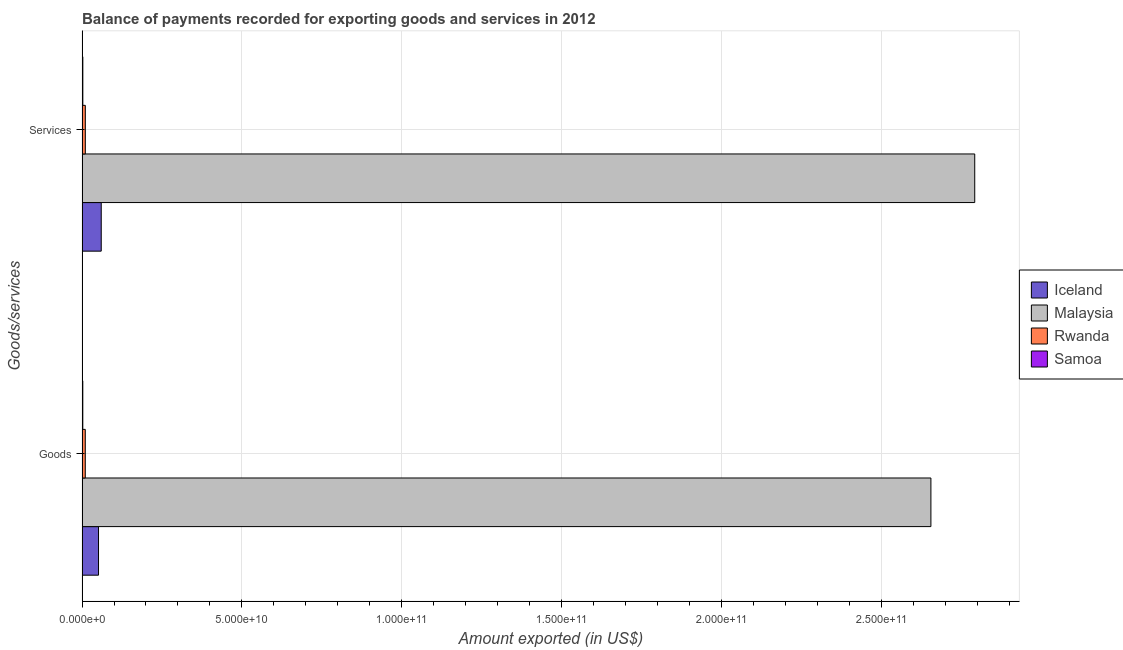How many different coloured bars are there?
Your response must be concise. 4. How many groups of bars are there?
Provide a succinct answer. 2. Are the number of bars per tick equal to the number of legend labels?
Your response must be concise. Yes. How many bars are there on the 1st tick from the top?
Your response must be concise. 4. What is the label of the 2nd group of bars from the top?
Keep it short and to the point. Goods. What is the amount of services exported in Malaysia?
Give a very brief answer. 2.79e+11. Across all countries, what is the maximum amount of services exported?
Your answer should be compact. 2.79e+11. Across all countries, what is the minimum amount of services exported?
Your answer should be compact. 2.51e+08. In which country was the amount of goods exported maximum?
Ensure brevity in your answer.  Malaysia. In which country was the amount of goods exported minimum?
Make the answer very short. Samoa. What is the total amount of goods exported in the graph?
Provide a succinct answer. 2.72e+11. What is the difference between the amount of services exported in Iceland and that in Samoa?
Your answer should be compact. 5.75e+09. What is the difference between the amount of goods exported in Samoa and the amount of services exported in Malaysia?
Offer a terse response. -2.79e+11. What is the average amount of services exported per country?
Keep it short and to the point. 7.16e+1. What is the difference between the amount of services exported and amount of goods exported in Malaysia?
Your answer should be compact. 1.37e+1. In how many countries, is the amount of services exported greater than 220000000000 US$?
Give a very brief answer. 1. What is the ratio of the amount of services exported in Rwanda to that in Samoa?
Give a very brief answer. 4.1. What does the 4th bar from the top in Services represents?
Your response must be concise. Iceland. What does the 3rd bar from the bottom in Services represents?
Provide a short and direct response. Rwanda. How many bars are there?
Keep it short and to the point. 8. How many countries are there in the graph?
Give a very brief answer. 4. What is the difference between two consecutive major ticks on the X-axis?
Give a very brief answer. 5.00e+1. Where does the legend appear in the graph?
Your answer should be compact. Center right. How are the legend labels stacked?
Give a very brief answer. Vertical. What is the title of the graph?
Provide a succinct answer. Balance of payments recorded for exporting goods and services in 2012. What is the label or title of the X-axis?
Offer a terse response. Amount exported (in US$). What is the label or title of the Y-axis?
Make the answer very short. Goods/services. What is the Amount exported (in US$) in Iceland in Goods?
Provide a short and direct response. 5.15e+09. What is the Amount exported (in US$) in Malaysia in Goods?
Ensure brevity in your answer.  2.66e+11. What is the Amount exported (in US$) of Rwanda in Goods?
Make the answer very short. 1.02e+09. What is the Amount exported (in US$) of Samoa in Goods?
Offer a very short reply. 2.42e+08. What is the Amount exported (in US$) in Iceland in Services?
Provide a succinct answer. 6.00e+09. What is the Amount exported (in US$) of Malaysia in Services?
Provide a short and direct response. 2.79e+11. What is the Amount exported (in US$) of Rwanda in Services?
Give a very brief answer. 1.03e+09. What is the Amount exported (in US$) of Samoa in Services?
Provide a short and direct response. 2.51e+08. Across all Goods/services, what is the maximum Amount exported (in US$) of Iceland?
Offer a very short reply. 6.00e+09. Across all Goods/services, what is the maximum Amount exported (in US$) in Malaysia?
Keep it short and to the point. 2.79e+11. Across all Goods/services, what is the maximum Amount exported (in US$) in Rwanda?
Ensure brevity in your answer.  1.03e+09. Across all Goods/services, what is the maximum Amount exported (in US$) in Samoa?
Provide a succinct answer. 2.51e+08. Across all Goods/services, what is the minimum Amount exported (in US$) in Iceland?
Your answer should be compact. 5.15e+09. Across all Goods/services, what is the minimum Amount exported (in US$) of Malaysia?
Make the answer very short. 2.66e+11. Across all Goods/services, what is the minimum Amount exported (in US$) of Rwanda?
Give a very brief answer. 1.02e+09. Across all Goods/services, what is the minimum Amount exported (in US$) in Samoa?
Ensure brevity in your answer.  2.42e+08. What is the total Amount exported (in US$) of Iceland in the graph?
Your answer should be very brief. 1.12e+1. What is the total Amount exported (in US$) of Malaysia in the graph?
Provide a short and direct response. 5.45e+11. What is the total Amount exported (in US$) of Rwanda in the graph?
Give a very brief answer. 2.04e+09. What is the total Amount exported (in US$) in Samoa in the graph?
Give a very brief answer. 4.93e+08. What is the difference between the Amount exported (in US$) in Iceland in Goods and that in Services?
Your response must be concise. -8.49e+08. What is the difference between the Amount exported (in US$) in Malaysia in Goods and that in Services?
Your answer should be very brief. -1.37e+1. What is the difference between the Amount exported (in US$) in Rwanda in Goods and that in Services?
Provide a short and direct response. -1.07e+07. What is the difference between the Amount exported (in US$) of Samoa in Goods and that in Services?
Make the answer very short. -8.47e+06. What is the difference between the Amount exported (in US$) in Iceland in Goods and the Amount exported (in US$) in Malaysia in Services?
Offer a terse response. -2.74e+11. What is the difference between the Amount exported (in US$) in Iceland in Goods and the Amount exported (in US$) in Rwanda in Services?
Provide a succinct answer. 4.13e+09. What is the difference between the Amount exported (in US$) of Iceland in Goods and the Amount exported (in US$) of Samoa in Services?
Offer a very short reply. 4.90e+09. What is the difference between the Amount exported (in US$) in Malaysia in Goods and the Amount exported (in US$) in Rwanda in Services?
Provide a short and direct response. 2.65e+11. What is the difference between the Amount exported (in US$) of Malaysia in Goods and the Amount exported (in US$) of Samoa in Services?
Your answer should be compact. 2.65e+11. What is the difference between the Amount exported (in US$) in Rwanda in Goods and the Amount exported (in US$) in Samoa in Services?
Ensure brevity in your answer.  7.65e+08. What is the average Amount exported (in US$) of Iceland per Goods/services?
Provide a short and direct response. 5.58e+09. What is the average Amount exported (in US$) of Malaysia per Goods/services?
Your answer should be compact. 2.72e+11. What is the average Amount exported (in US$) in Rwanda per Goods/services?
Ensure brevity in your answer.  1.02e+09. What is the average Amount exported (in US$) of Samoa per Goods/services?
Provide a short and direct response. 2.46e+08. What is the difference between the Amount exported (in US$) in Iceland and Amount exported (in US$) in Malaysia in Goods?
Your answer should be very brief. -2.60e+11. What is the difference between the Amount exported (in US$) in Iceland and Amount exported (in US$) in Rwanda in Goods?
Offer a very short reply. 4.14e+09. What is the difference between the Amount exported (in US$) of Iceland and Amount exported (in US$) of Samoa in Goods?
Offer a terse response. 4.91e+09. What is the difference between the Amount exported (in US$) of Malaysia and Amount exported (in US$) of Rwanda in Goods?
Your answer should be compact. 2.65e+11. What is the difference between the Amount exported (in US$) in Malaysia and Amount exported (in US$) in Samoa in Goods?
Give a very brief answer. 2.65e+11. What is the difference between the Amount exported (in US$) in Rwanda and Amount exported (in US$) in Samoa in Goods?
Make the answer very short. 7.74e+08. What is the difference between the Amount exported (in US$) in Iceland and Amount exported (in US$) in Malaysia in Services?
Your answer should be compact. -2.73e+11. What is the difference between the Amount exported (in US$) in Iceland and Amount exported (in US$) in Rwanda in Services?
Give a very brief answer. 4.98e+09. What is the difference between the Amount exported (in US$) in Iceland and Amount exported (in US$) in Samoa in Services?
Your answer should be compact. 5.75e+09. What is the difference between the Amount exported (in US$) of Malaysia and Amount exported (in US$) of Rwanda in Services?
Your answer should be compact. 2.78e+11. What is the difference between the Amount exported (in US$) in Malaysia and Amount exported (in US$) in Samoa in Services?
Provide a short and direct response. 2.79e+11. What is the difference between the Amount exported (in US$) in Rwanda and Amount exported (in US$) in Samoa in Services?
Ensure brevity in your answer.  7.76e+08. What is the ratio of the Amount exported (in US$) in Iceland in Goods to that in Services?
Your answer should be very brief. 0.86. What is the ratio of the Amount exported (in US$) in Malaysia in Goods to that in Services?
Provide a short and direct response. 0.95. What is the ratio of the Amount exported (in US$) of Rwanda in Goods to that in Services?
Provide a short and direct response. 0.99. What is the ratio of the Amount exported (in US$) in Samoa in Goods to that in Services?
Ensure brevity in your answer.  0.97. What is the difference between the highest and the second highest Amount exported (in US$) in Iceland?
Your response must be concise. 8.49e+08. What is the difference between the highest and the second highest Amount exported (in US$) in Malaysia?
Your answer should be very brief. 1.37e+1. What is the difference between the highest and the second highest Amount exported (in US$) of Rwanda?
Offer a terse response. 1.07e+07. What is the difference between the highest and the second highest Amount exported (in US$) in Samoa?
Ensure brevity in your answer.  8.47e+06. What is the difference between the highest and the lowest Amount exported (in US$) in Iceland?
Offer a terse response. 8.49e+08. What is the difference between the highest and the lowest Amount exported (in US$) of Malaysia?
Offer a terse response. 1.37e+1. What is the difference between the highest and the lowest Amount exported (in US$) in Rwanda?
Your answer should be compact. 1.07e+07. What is the difference between the highest and the lowest Amount exported (in US$) of Samoa?
Keep it short and to the point. 8.47e+06. 